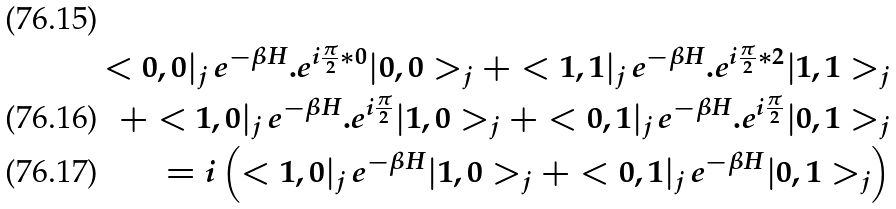Convert formula to latex. <formula><loc_0><loc_0><loc_500><loc_500>< 0 , 0 | _ { j } \, e ^ { - \beta H } . e ^ { i \frac { \pi } { 2 } * 0 } | 0 , 0 > _ { j } + < 1 , 1 | _ { j } \, e ^ { - \beta H } . e ^ { i \frac { \pi } { 2 } * 2 } | 1 , 1 > _ { j } \\ + < 1 , 0 | _ { j } \, e ^ { - \beta H } . e ^ { i \frac { \pi } { 2 } } | 1 , 0 > _ { j } + < 0 , 1 | _ { j } \, e ^ { - \beta H } . e ^ { i \frac { \pi } { 2 } } | 0 , 1 > _ { j } \\ = i \left ( < 1 , 0 | _ { j } \, e ^ { - \beta H } | 1 , 0 > _ { j } + < 0 , 1 | _ { j } \, e ^ { - \beta H } | 0 , 1 > _ { j } \right )</formula> 